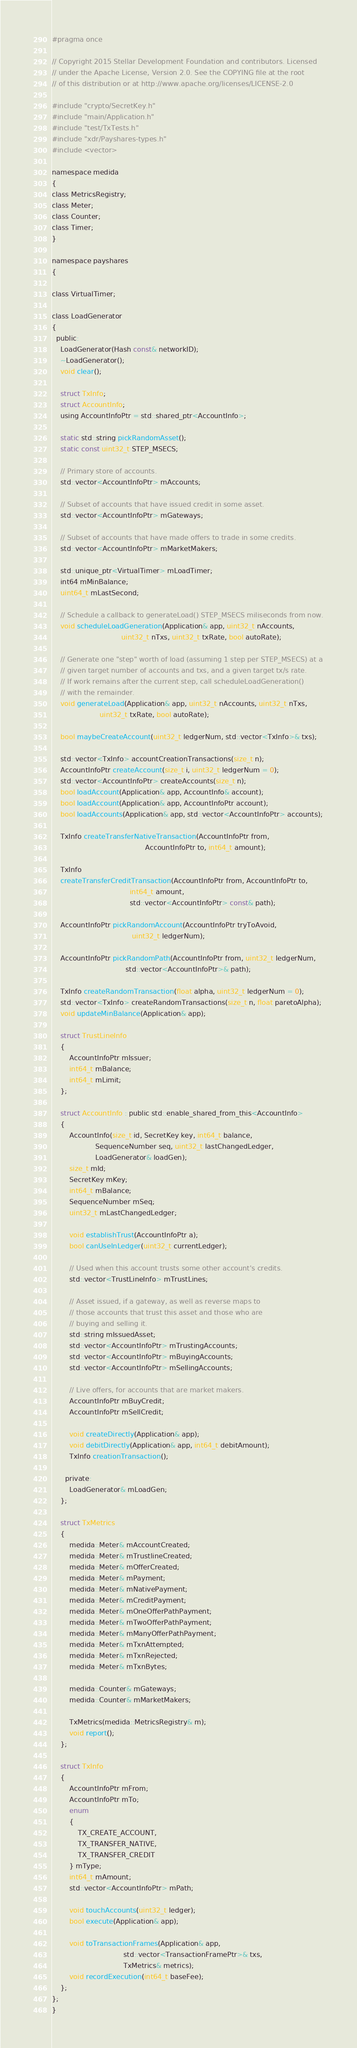<code> <loc_0><loc_0><loc_500><loc_500><_C_>#pragma once

// Copyright 2015 Stellar Development Foundation and contributors. Licensed
// under the Apache License, Version 2.0. See the COPYING file at the root
// of this distribution or at http://www.apache.org/licenses/LICENSE-2.0

#include "crypto/SecretKey.h"
#include "main/Application.h"
#include "test/TxTests.h"
#include "xdr/Payshares-types.h"
#include <vector>

namespace medida
{
class MetricsRegistry;
class Meter;
class Counter;
class Timer;
}

namespace payshares
{

class VirtualTimer;

class LoadGenerator
{
  public:
    LoadGenerator(Hash const& networkID);
    ~LoadGenerator();
    void clear();

    struct TxInfo;
    struct AccountInfo;
    using AccountInfoPtr = std::shared_ptr<AccountInfo>;

    static std::string pickRandomAsset();
    static const uint32_t STEP_MSECS;

    // Primary store of accounts.
    std::vector<AccountInfoPtr> mAccounts;

    // Subset of accounts that have issued credit in some asset.
    std::vector<AccountInfoPtr> mGateways;

    // Subset of accounts that have made offers to trade in some credits.
    std::vector<AccountInfoPtr> mMarketMakers;

    std::unique_ptr<VirtualTimer> mLoadTimer;
    int64 mMinBalance;
    uint64_t mLastSecond;

    // Schedule a callback to generateLoad() STEP_MSECS miliseconds from now.
    void scheduleLoadGeneration(Application& app, uint32_t nAccounts,
                                uint32_t nTxs, uint32_t txRate, bool autoRate);

    // Generate one "step" worth of load (assuming 1 step per STEP_MSECS) at a
    // given target number of accounts and txs, and a given target tx/s rate.
    // If work remains after the current step, call scheduleLoadGeneration()
    // with the remainder.
    void generateLoad(Application& app, uint32_t nAccounts, uint32_t nTxs,
                      uint32_t txRate, bool autoRate);

    bool maybeCreateAccount(uint32_t ledgerNum, std::vector<TxInfo>& txs);

    std::vector<TxInfo> accountCreationTransactions(size_t n);
    AccountInfoPtr createAccount(size_t i, uint32_t ledgerNum = 0);
    std::vector<AccountInfoPtr> createAccounts(size_t n);
    bool loadAccount(Application& app, AccountInfo& account);
    bool loadAccount(Application& app, AccountInfoPtr account);
    bool loadAccounts(Application& app, std::vector<AccountInfoPtr> accounts);

    TxInfo createTransferNativeTransaction(AccountInfoPtr from,
                                           AccountInfoPtr to, int64_t amount);

    TxInfo
    createTransferCreditTransaction(AccountInfoPtr from, AccountInfoPtr to,
                                    int64_t amount,
                                    std::vector<AccountInfoPtr> const& path);

    AccountInfoPtr pickRandomAccount(AccountInfoPtr tryToAvoid,
                                     uint32_t ledgerNum);

    AccountInfoPtr pickRandomPath(AccountInfoPtr from, uint32_t ledgerNum,
                                  std::vector<AccountInfoPtr>& path);

    TxInfo createRandomTransaction(float alpha, uint32_t ledgerNum = 0);
    std::vector<TxInfo> createRandomTransactions(size_t n, float paretoAlpha);
    void updateMinBalance(Application& app);

    struct TrustLineInfo
    {
        AccountInfoPtr mIssuer;
        int64_t mBalance;
        int64_t mLimit;
    };

    struct AccountInfo : public std::enable_shared_from_this<AccountInfo>
    {
        AccountInfo(size_t id, SecretKey key, int64_t balance,
                    SequenceNumber seq, uint32_t lastChangedLedger,
                    LoadGenerator& loadGen);
        size_t mId;
        SecretKey mKey;
        int64_t mBalance;
        SequenceNumber mSeq;
        uint32_t mLastChangedLedger;

        void establishTrust(AccountInfoPtr a);
        bool canUseInLedger(uint32_t currentLedger);

        // Used when this account trusts some other account's credits.
        std::vector<TrustLineInfo> mTrustLines;

        // Asset issued, if a gateway, as well as reverse maps to
        // those accounts that trust this asset and those who are
        // buying and selling it.
        std::string mIssuedAsset;
        std::vector<AccountInfoPtr> mTrustingAccounts;
        std::vector<AccountInfoPtr> mBuyingAccounts;
        std::vector<AccountInfoPtr> mSellingAccounts;

        // Live offers, for accounts that are market makers.
        AccountInfoPtr mBuyCredit;
        AccountInfoPtr mSellCredit;

        void createDirectly(Application& app);
        void debitDirectly(Application& app, int64_t debitAmount);
        TxInfo creationTransaction();

      private:
        LoadGenerator& mLoadGen;
    };

    struct TxMetrics
    {
        medida::Meter& mAccountCreated;
        medida::Meter& mTrustlineCreated;
        medida::Meter& mOfferCreated;
        medida::Meter& mPayment;
        medida::Meter& mNativePayment;
        medida::Meter& mCreditPayment;
        medida::Meter& mOneOfferPathPayment;
        medida::Meter& mTwoOfferPathPayment;
        medida::Meter& mManyOfferPathPayment;
        medida::Meter& mTxnAttempted;
        medida::Meter& mTxnRejected;
        medida::Meter& mTxnBytes;

        medida::Counter& mGateways;
        medida::Counter& mMarketMakers;

        TxMetrics(medida::MetricsRegistry& m);
        void report();
    };

    struct TxInfo
    {
        AccountInfoPtr mFrom;
        AccountInfoPtr mTo;
        enum
        {
            TX_CREATE_ACCOUNT,
            TX_TRANSFER_NATIVE,
            TX_TRANSFER_CREDIT
        } mType;
        int64_t mAmount;
        std::vector<AccountInfoPtr> mPath;

        void touchAccounts(uint32_t ledger);
        bool execute(Application& app);

        void toTransactionFrames(Application& app,
                                 std::vector<TransactionFramePtr>& txs,
                                 TxMetrics& metrics);
        void recordExecution(int64_t baseFee);
    };
};
}
</code> 